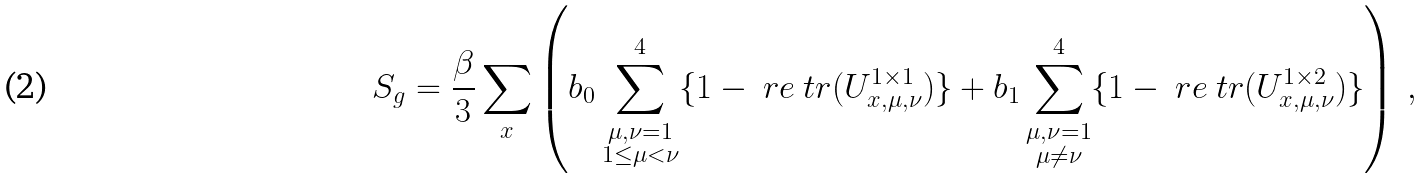<formula> <loc_0><loc_0><loc_500><loc_500>S _ { g } = \frac { \beta } { 3 } \sum _ { x } \left ( b _ { 0 } \sum _ { \substack { \mu , \nu = 1 \\ 1 \leq \mu < \nu } } ^ { 4 } \{ 1 - \ r e \ t r ( U ^ { 1 \times 1 } _ { x , \mu , \nu } ) \} \Big . \Big . + b _ { 1 } \sum _ { \substack { \mu , \nu = 1 \\ \mu \neq \nu } } ^ { 4 } \{ 1 - \ r e \ t r ( U ^ { 1 \times 2 } _ { x , \mu , \nu } ) \} \right ) \, ,</formula> 